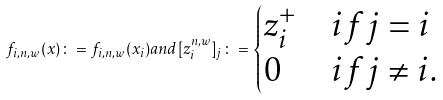Convert formula to latex. <formula><loc_0><loc_0><loc_500><loc_500>f _ { i , n , w } ( { x } ) \colon = f _ { i , n , w } ( { x } _ { i } ) a n d [ { z } _ { i } ^ { n , w } ] _ { j } \colon = \begin{cases} { z } _ { i } ^ { + } & i f j = i \\ 0 & i f j \neq i . \end{cases}</formula> 